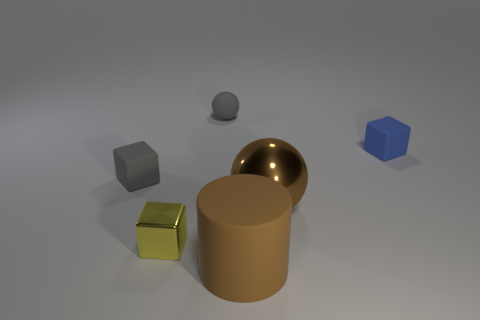Subtract all matte cubes. How many cubes are left? 1 Subtract 1 cubes. How many cubes are left? 2 Add 4 tiny brown shiny spheres. How many objects exist? 10 Subtract all spheres. How many objects are left? 4 Subtract all shiny spheres. Subtract all small gray rubber things. How many objects are left? 3 Add 5 large objects. How many large objects are left? 7 Add 5 small gray matte things. How many small gray matte things exist? 7 Subtract 0 red cylinders. How many objects are left? 6 